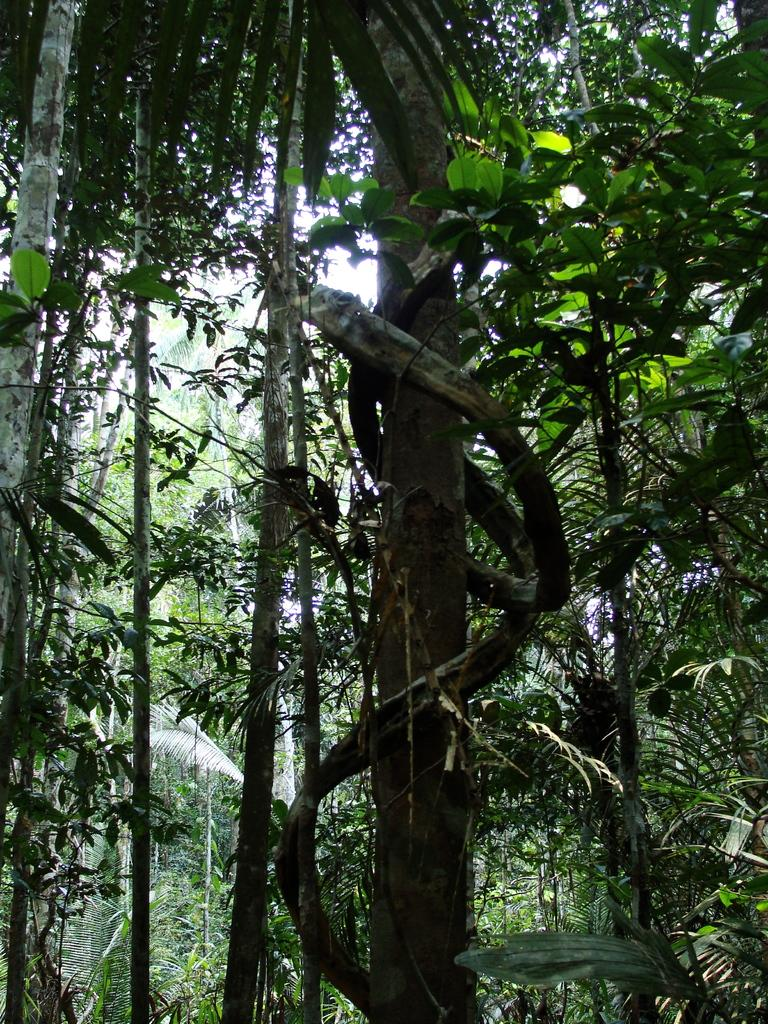What type of vegetation can be seen in the image? There are trees in the image. What type of wire is holding the cannon in the image? There is no wire or cannon present in the image; it only features trees. Who is the owner of the trees in the image? The image does not provide information about the ownership of the trees, so it cannot be determined from the image. 